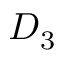<formula> <loc_0><loc_0><loc_500><loc_500>D _ { 3 }</formula> 